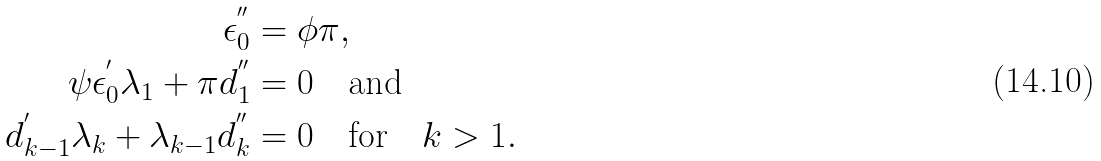<formula> <loc_0><loc_0><loc_500><loc_500>\epsilon _ { 0 } ^ { ^ { \prime \prime } } & = \phi \pi , \\ \psi \epsilon _ { 0 } ^ { ^ { \prime } } \lambda _ { 1 } + \pi d _ { 1 } ^ { ^ { \prime \prime } } & = 0 \quad \text {and} \\ d _ { k - 1 } ^ { ^ { \prime } } \lambda _ { k } + \lambda _ { k - 1 } d _ { k } ^ { ^ { \prime \prime } } & = 0 \quad \text {for} \quad k > 1 .</formula> 